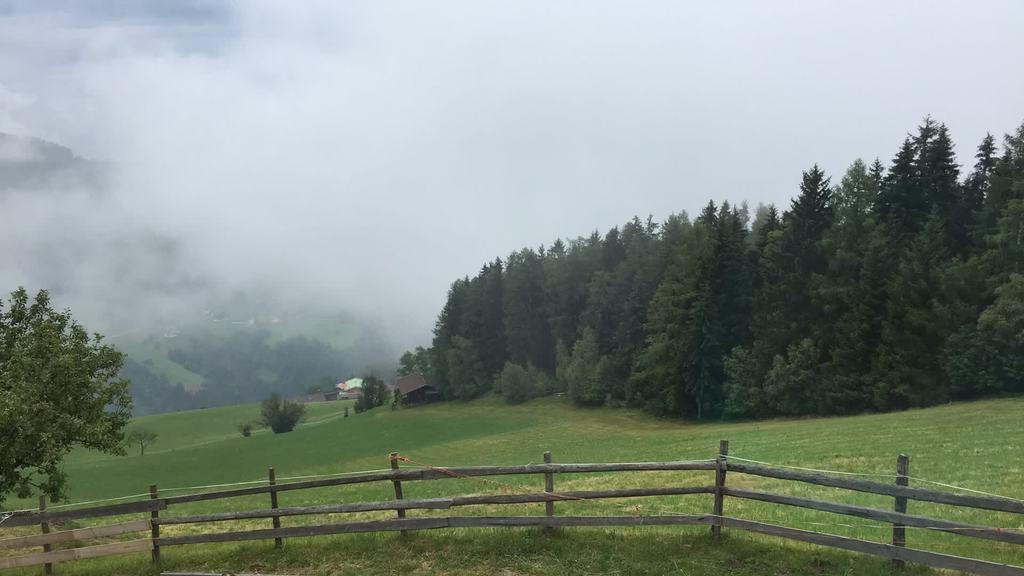What type of ground cover is present in the front of the image? There is grass on the ground in the front of the image. What type of barrier is present in the front of the image? There is a wooden fence in the front of the image. What can be seen in the background of the image? There are trees and houses in the background of the image. What type of ground cover is present in the background of the image? There is grass on the ground in the background of the image. What is visible in the image that might indicate some activity or event? There is smoke visible in the image. What type of ink is being used to write on the wooden fence in the image? There is no ink or writing present on the wooden fence in the image. How many bikes are visible in the image? There are no bikes visible in the image. 